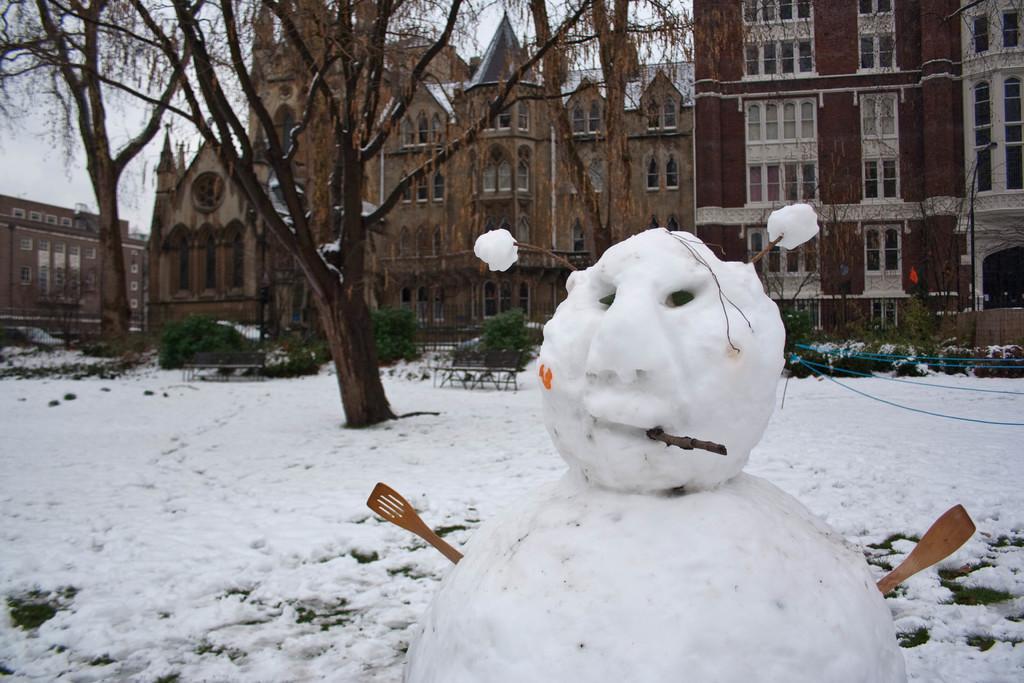Describe this image in one or two sentences. In the image we can see there is a snowman standing on the ground and the ground is covered with snow. Behind there are trees and there are buildings. 